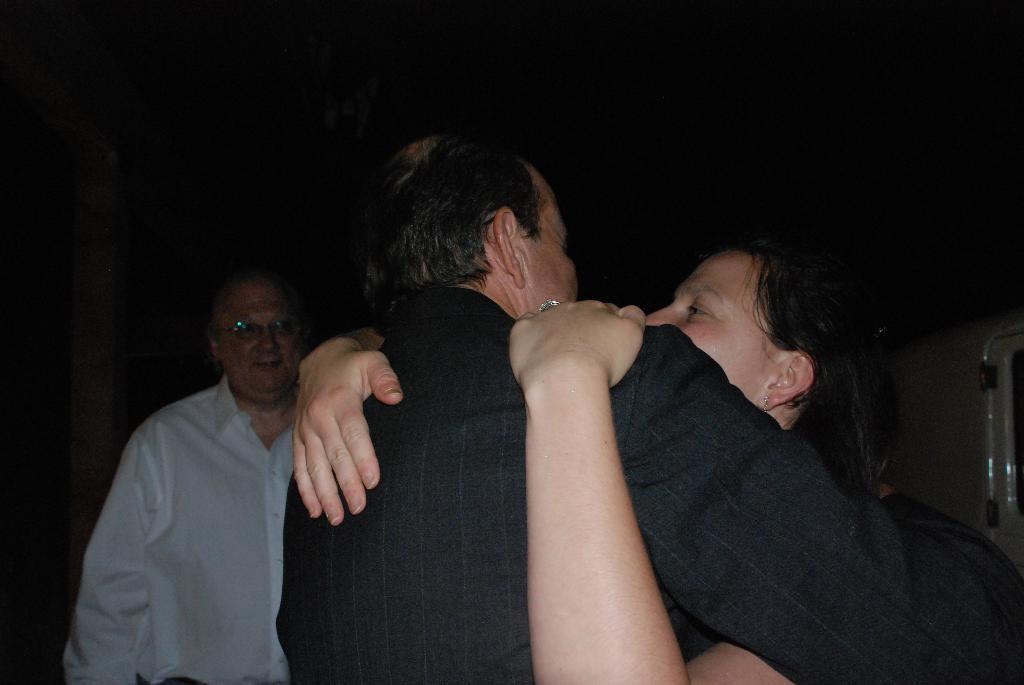Can you describe this image briefly? In this image we can see these two people are hugging each other and we can see this person wearing a white shirt and spectacles is standing here. The background of the image is dark. 